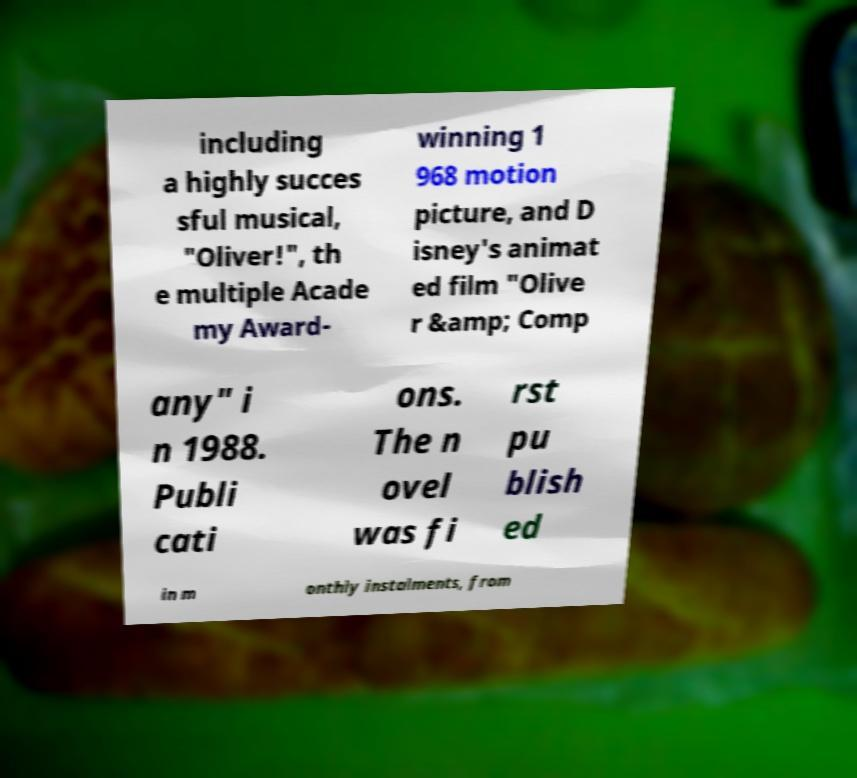I need the written content from this picture converted into text. Can you do that? including a highly succes sful musical, "Oliver!", th e multiple Acade my Award- winning 1 968 motion picture, and D isney's animat ed film "Olive r &amp; Comp any" i n 1988. Publi cati ons. The n ovel was fi rst pu blish ed in m onthly instalments, from 